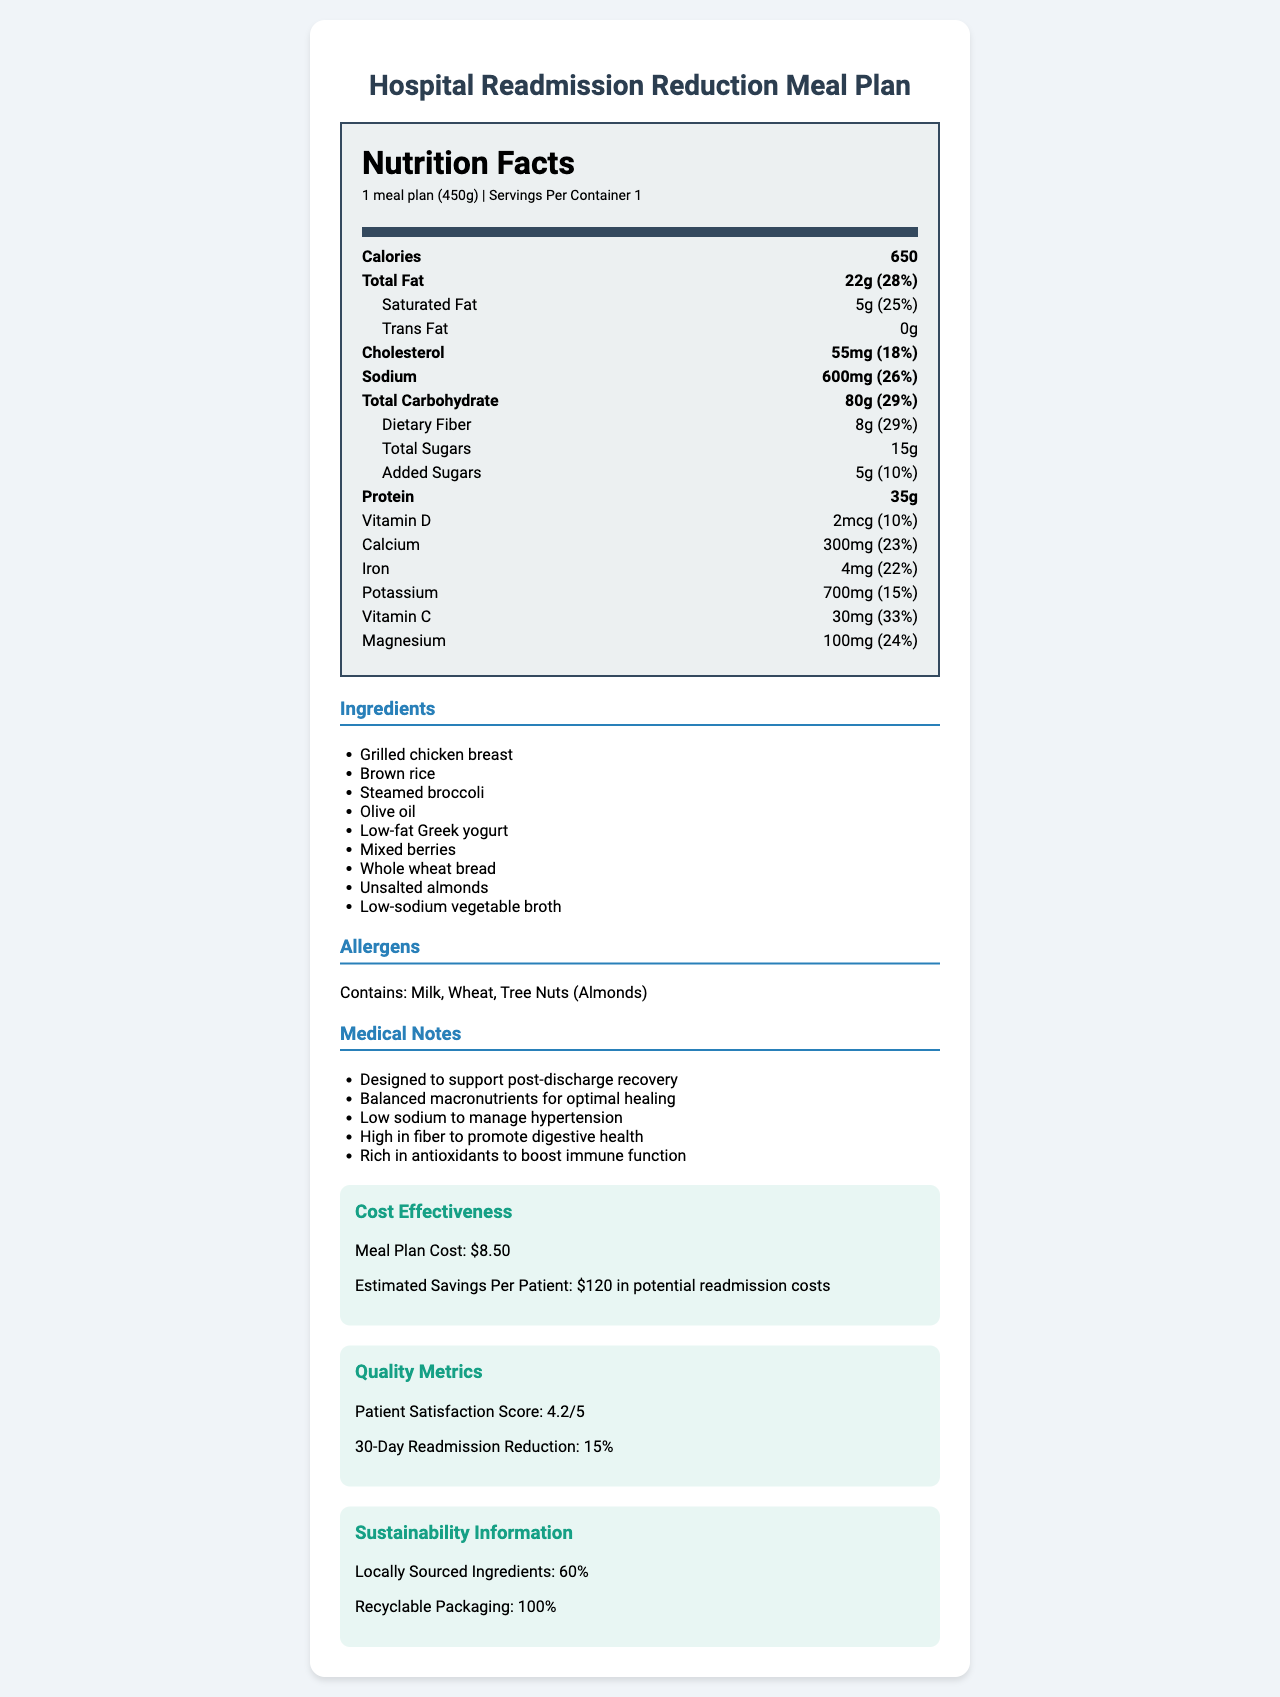what is the serving size of the meal plan? The serving size is explicitly mentioned as "1 meal plan (450g)" in the document.
Answer: 1 meal plan (450g) how many calories are in one serving of the meal plan? The document lists the calorie content as 650.
Answer: 650 calories what is the total fat content and its daily value percentage? The total fat content is 22g, which corresponds to 28% of the daily value.
Answer: 22g, 28% how much dietary fiber does the meal plan have? According to the document, the dietary fiber content is 8g.
Answer: 8g what are the potential allergens in this meal plan? The allergens section lists the potential allergens as "Contains: Milk, Wheat, Tree Nuts (Almonds)".
Answer: Milk, Wheat, Tree Nuts (Almonds) how much sodium is in the meal plan? The sodium content is clearly indicated as 600mg in the document.
Answer: 600mg what is the patient's estimated savings per meal plan to prevent readmission? The document states that the estimated savings per patient is "$120 in potential readmission costs".
Answer: $120 in potential readmission costs which nutrient has the highest daily value percentage? A. Vitamin C B. Calcium C. Dietary Fiber D. Saturated Fat The highest daily value percentage listed in the document is for Vitamin C at 33%.
Answer: A. Vitamin C how many grams of protein does the meal plan provide? The document provides the protein content as 35g.
Answer: 35g which statement is true about the sustainability of the meal plan? i. Recyclable packaging ii. Locally sourced ingredients (80%) iii. Locally sourced ingredients (60%) iv. No recyclable packaging The document states that the meal has "locally sourced ingredients: 60%" and "recyclable packaging: 100%".
Answer: i. Recyclable packaging, iii. Locally sourced ingredients (60%) is the meal plan designed to support post-discharge recovery? One of the medical notes clearly states that it is "Designed to support post-discharge recovery".
Answer: Yes summarize the main idea of the document. The summary includes information about the meal's nutritional content, medical benefits, economic impact, patient satisfaction, and sustainability.
Answer: The document provides detailed nutritional information, ingredients, allergens, medical notes, cost-effectiveness, quality metrics, and sustainability information about a hospital meal plan designed to reduce readmission rates. what is the macronutrient breakdown of the meal plan? The document does not provide explicit macronutrient breakdown details such as percentages of carbohydrates, proteins, and fats.
Answer: Cannot be determined 